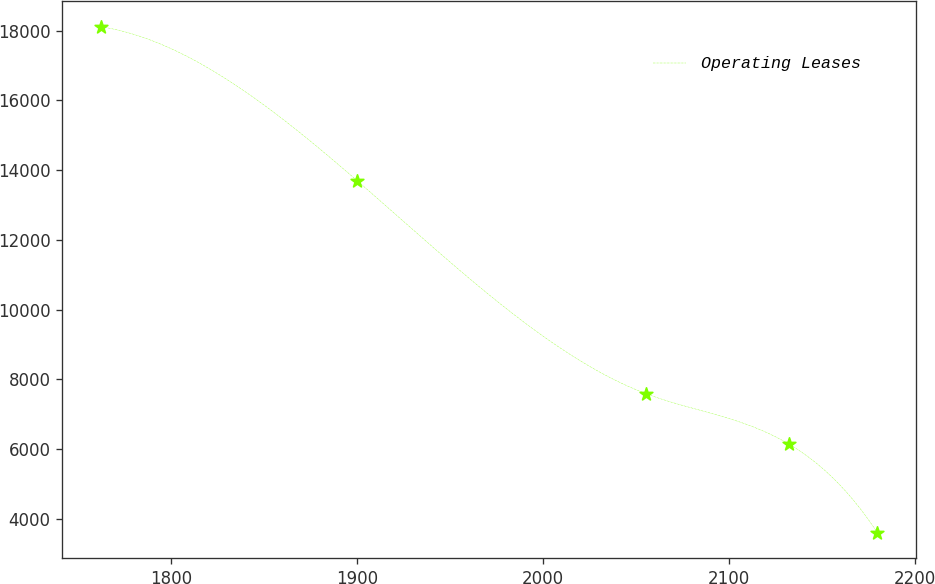Convert chart. <chart><loc_0><loc_0><loc_500><loc_500><line_chart><ecel><fcel>Operating Leases<nl><fcel>1762.57<fcel>18109.9<nl><fcel>1900.27<fcel>13693<nl><fcel>2055.4<fcel>7589.3<nl><fcel>2132.5<fcel>6137.76<nl><fcel>2180.04<fcel>3594.51<nl></chart> 